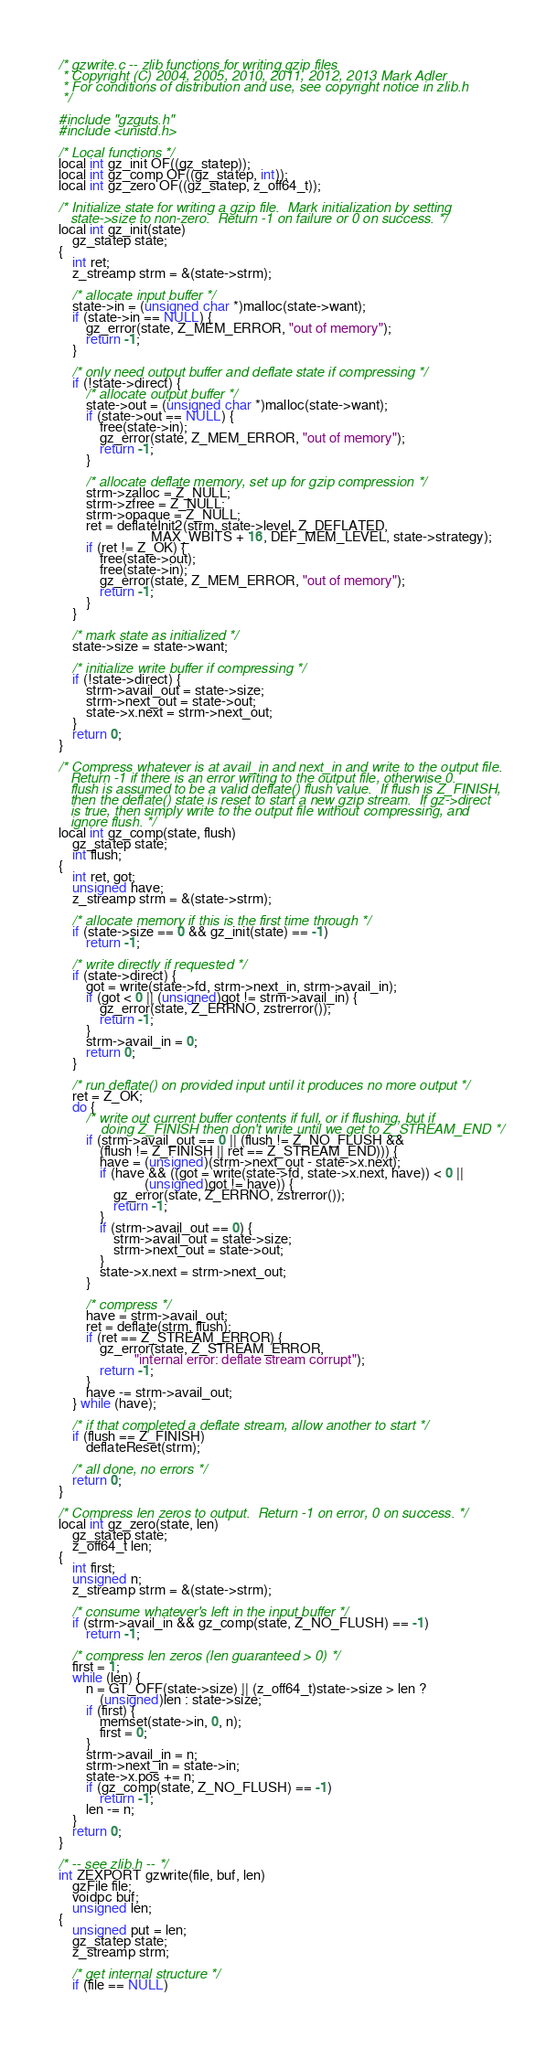<code> <loc_0><loc_0><loc_500><loc_500><_C_>/* gzwrite.c -- zlib functions for writing gzip files
 * Copyright (C) 2004, 2005, 2010, 2011, 2012, 2013 Mark Adler
 * For conditions of distribution and use, see copyright notice in zlib.h
 */

#include "gzguts.h"
#include <unistd.h> 

/* Local functions */
local int gz_init OF((gz_statep));
local int gz_comp OF((gz_statep, int));
local int gz_zero OF((gz_statep, z_off64_t));

/* Initialize state for writing a gzip file.  Mark initialization by setting
   state->size to non-zero.  Return -1 on failure or 0 on success. */
local int gz_init(state)
    gz_statep state;
{
    int ret;
    z_streamp strm = &(state->strm);

    /* allocate input buffer */
    state->in = (unsigned char *)malloc(state->want);
    if (state->in == NULL) {
        gz_error(state, Z_MEM_ERROR, "out of memory");
        return -1;
    }

    /* only need output buffer and deflate state if compressing */
    if (!state->direct) {
        /* allocate output buffer */
        state->out = (unsigned char *)malloc(state->want);
        if (state->out == NULL) {
            free(state->in);
            gz_error(state, Z_MEM_ERROR, "out of memory");
            return -1;
        }

        /* allocate deflate memory, set up for gzip compression */
        strm->zalloc = Z_NULL;
        strm->zfree = Z_NULL;
        strm->opaque = Z_NULL;
        ret = deflateInit2(strm, state->level, Z_DEFLATED,
                           MAX_WBITS + 16, DEF_MEM_LEVEL, state->strategy);
        if (ret != Z_OK) {
            free(state->out);
            free(state->in);
            gz_error(state, Z_MEM_ERROR, "out of memory");
            return -1;
        }
    }

    /* mark state as initialized */
    state->size = state->want;

    /* initialize write buffer if compressing */
    if (!state->direct) {
        strm->avail_out = state->size;
        strm->next_out = state->out;
        state->x.next = strm->next_out;
    }
    return 0;
}

/* Compress whatever is at avail_in and next_in and write to the output file.
   Return -1 if there is an error writing to the output file, otherwise 0.
   flush is assumed to be a valid deflate() flush value.  If flush is Z_FINISH,
   then the deflate() state is reset to start a new gzip stream.  If gz->direct
   is true, then simply write to the output file without compressing, and
   ignore flush. */
local int gz_comp(state, flush)
    gz_statep state;
    int flush;
{
    int ret, got;
    unsigned have;
    z_streamp strm = &(state->strm);

    /* allocate memory if this is the first time through */
    if (state->size == 0 && gz_init(state) == -1)
        return -1;

    /* write directly if requested */
    if (state->direct) {
        got = write(state->fd, strm->next_in, strm->avail_in);
        if (got < 0 || (unsigned)got != strm->avail_in) {
            gz_error(state, Z_ERRNO, zstrerror());
            return -1;
        }
        strm->avail_in = 0;
        return 0;
    }

    /* run deflate() on provided input until it produces no more output */
    ret = Z_OK;
    do {
        /* write out current buffer contents if full, or if flushing, but if
           doing Z_FINISH then don't write until we get to Z_STREAM_END */
        if (strm->avail_out == 0 || (flush != Z_NO_FLUSH &&
            (flush != Z_FINISH || ret == Z_STREAM_END))) {
            have = (unsigned)(strm->next_out - state->x.next);
            if (have && ((got = write(state->fd, state->x.next, have)) < 0 ||
                         (unsigned)got != have)) {
                gz_error(state, Z_ERRNO, zstrerror());
                return -1;
            }
            if (strm->avail_out == 0) {
                strm->avail_out = state->size;
                strm->next_out = state->out;
            }
            state->x.next = strm->next_out;
        }

        /* compress */
        have = strm->avail_out;
        ret = deflate(strm, flush);
        if (ret == Z_STREAM_ERROR) {
            gz_error(state, Z_STREAM_ERROR,
                      "internal error: deflate stream corrupt");
            return -1;
        }
        have -= strm->avail_out;
    } while (have);

    /* if that completed a deflate stream, allow another to start */
    if (flush == Z_FINISH)
        deflateReset(strm);

    /* all done, no errors */
    return 0;
}

/* Compress len zeros to output.  Return -1 on error, 0 on success. */
local int gz_zero(state, len)
    gz_statep state;
    z_off64_t len;
{
    int first;
    unsigned n;
    z_streamp strm = &(state->strm);

    /* consume whatever's left in the input buffer */
    if (strm->avail_in && gz_comp(state, Z_NO_FLUSH) == -1)
        return -1;

    /* compress len zeros (len guaranteed > 0) */
    first = 1;
    while (len) {
        n = GT_OFF(state->size) || (z_off64_t)state->size > len ?
            (unsigned)len : state->size;
        if (first) {
            memset(state->in, 0, n);
            first = 0;
        }
        strm->avail_in = n;
        strm->next_in = state->in;
        state->x.pos += n;
        if (gz_comp(state, Z_NO_FLUSH) == -1)
            return -1;
        len -= n;
    }
    return 0;
}

/* -- see zlib.h -- */
int ZEXPORT gzwrite(file, buf, len)
    gzFile file;
    voidpc buf;
    unsigned len;
{
    unsigned put = len;
    gz_statep state;
    z_streamp strm;

    /* get internal structure */
    if (file == NULL)</code> 